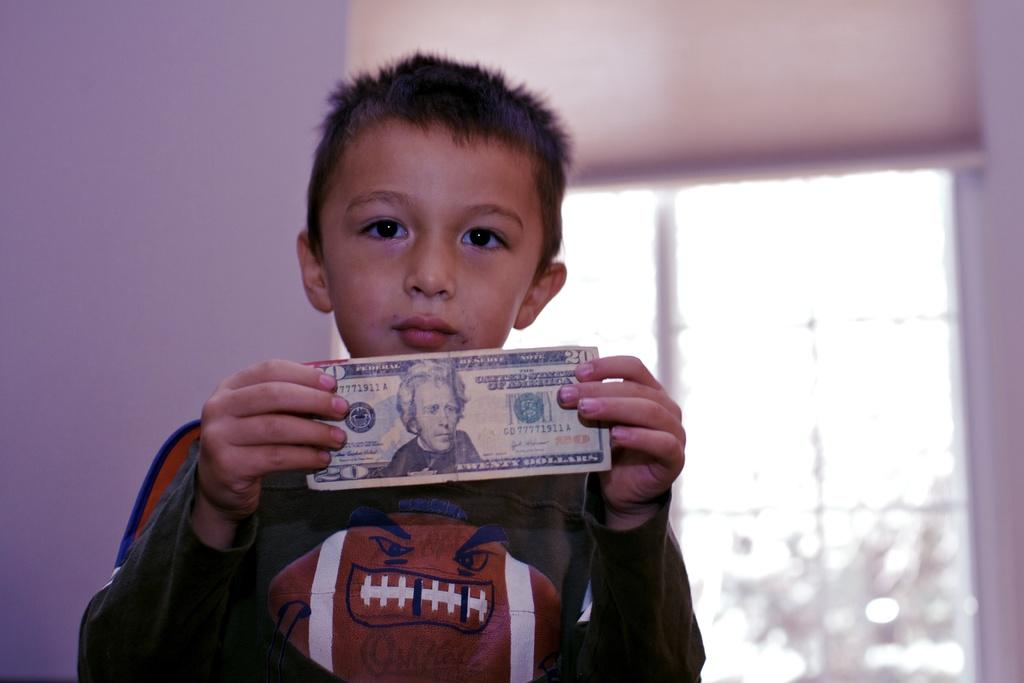Provide a one-sentence caption for the provided image. A young male wears a football shirt while holding a twenty dollar bill up. 